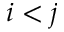Convert formula to latex. <formula><loc_0><loc_0><loc_500><loc_500>i < j</formula> 